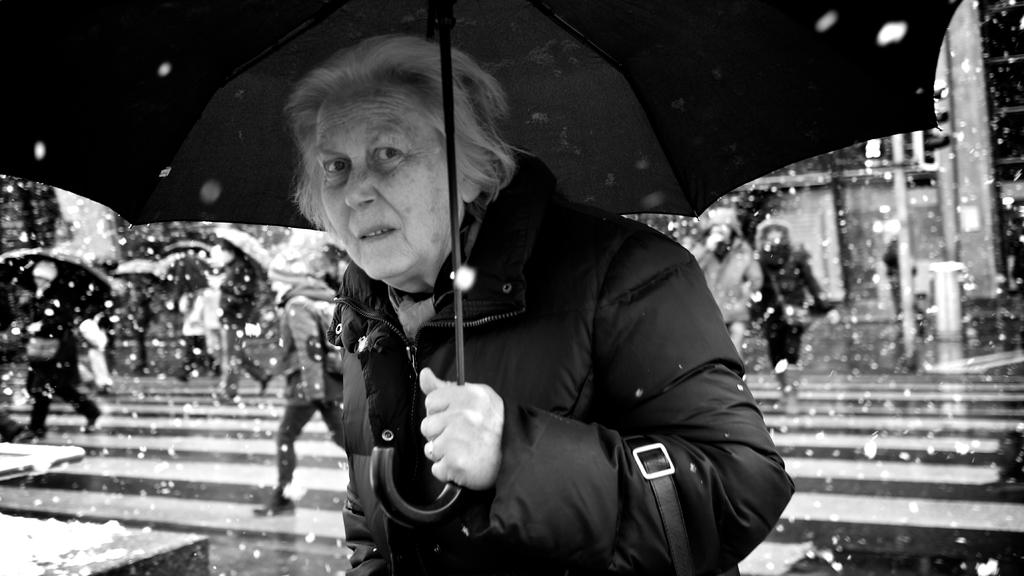What is the color scheme of the image? The image is black and white. What is the person in the image wearing? The person is wearing a jacket. What object is the person holding? The person is holding an umbrella. What can be observed about the people in the background? There are people walking in the background. Can you describe the objects in the background? The objects in the background are blurred. Is there a woman in jail in the image? There is no woman or jail present in the image. Can you see steam coming from the person's jacket in the image? There is no steam visible in the image. 